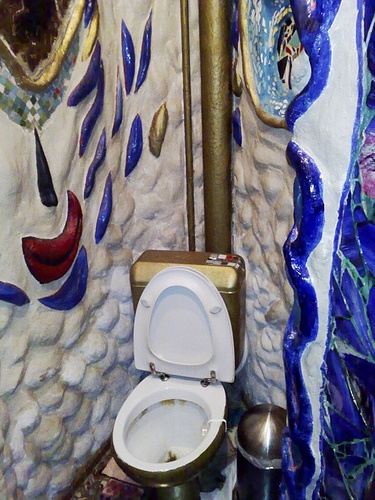Describe the objects in this image and their specific colors. I can see a toilet in gray, lightgray, darkgray, and black tones in this image. 